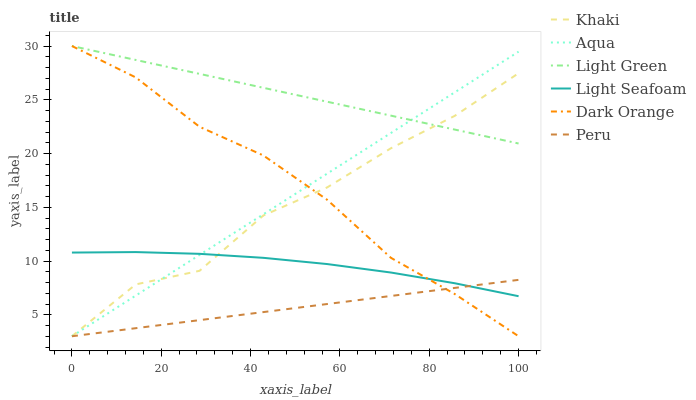Does Khaki have the minimum area under the curve?
Answer yes or no. No. Does Khaki have the maximum area under the curve?
Answer yes or no. No. Is Light Green the smoothest?
Answer yes or no. No. Is Light Green the roughest?
Answer yes or no. No. Does Light Green have the lowest value?
Answer yes or no. No. Does Khaki have the highest value?
Answer yes or no. No. Is Light Seafoam less than Light Green?
Answer yes or no. Yes. Is Light Green greater than Light Seafoam?
Answer yes or no. Yes. Does Light Seafoam intersect Light Green?
Answer yes or no. No. 